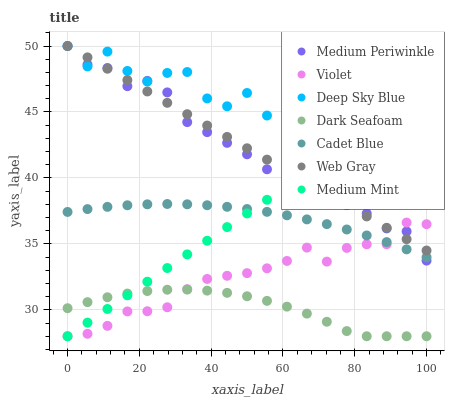Does Dark Seafoam have the minimum area under the curve?
Answer yes or no. Yes. Does Deep Sky Blue have the maximum area under the curve?
Answer yes or no. Yes. Does Web Gray have the minimum area under the curve?
Answer yes or no. No. Does Web Gray have the maximum area under the curve?
Answer yes or no. No. Is Medium Mint the smoothest?
Answer yes or no. Yes. Is Deep Sky Blue the roughest?
Answer yes or no. Yes. Is Web Gray the smoothest?
Answer yes or no. No. Is Web Gray the roughest?
Answer yes or no. No. Does Medium Mint have the lowest value?
Answer yes or no. Yes. Does Web Gray have the lowest value?
Answer yes or no. No. Does Deep Sky Blue have the highest value?
Answer yes or no. Yes. Does Dark Seafoam have the highest value?
Answer yes or no. No. Is Dark Seafoam less than Medium Periwinkle?
Answer yes or no. Yes. Is Deep Sky Blue greater than Cadet Blue?
Answer yes or no. Yes. Does Violet intersect Medium Mint?
Answer yes or no. Yes. Is Violet less than Medium Mint?
Answer yes or no. No. Is Violet greater than Medium Mint?
Answer yes or no. No. Does Dark Seafoam intersect Medium Periwinkle?
Answer yes or no. No. 